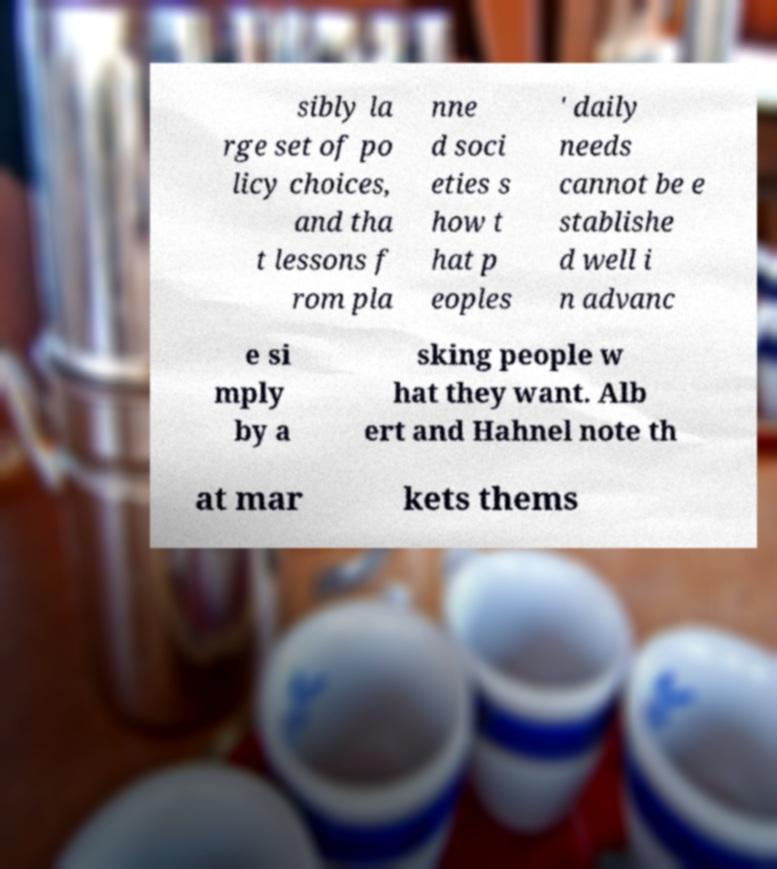Could you assist in decoding the text presented in this image and type it out clearly? sibly la rge set of po licy choices, and tha t lessons f rom pla nne d soci eties s how t hat p eoples ' daily needs cannot be e stablishe d well i n advanc e si mply by a sking people w hat they want. Alb ert and Hahnel note th at mar kets thems 